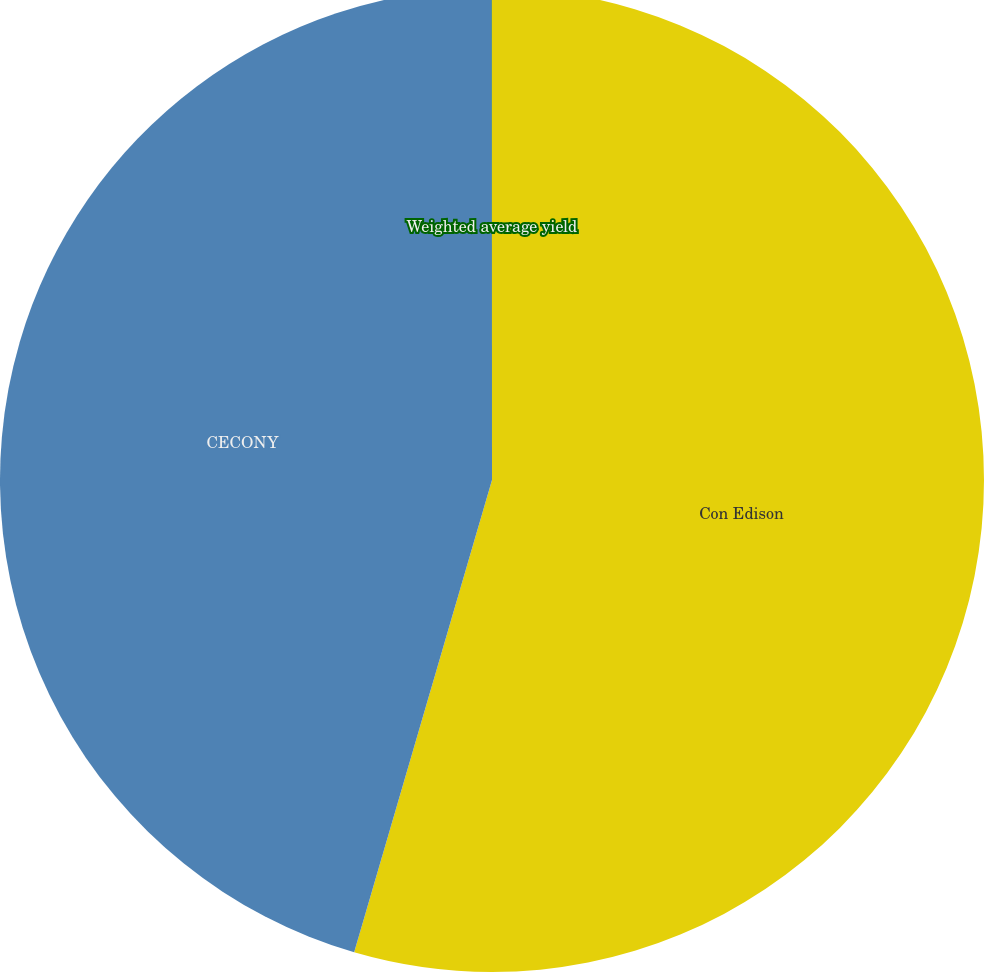Convert chart to OTSL. <chart><loc_0><loc_0><loc_500><loc_500><pie_chart><fcel>Con Edison<fcel>CECONY<fcel>Weighted average yield<nl><fcel>54.52%<fcel>45.47%<fcel>0.01%<nl></chart> 